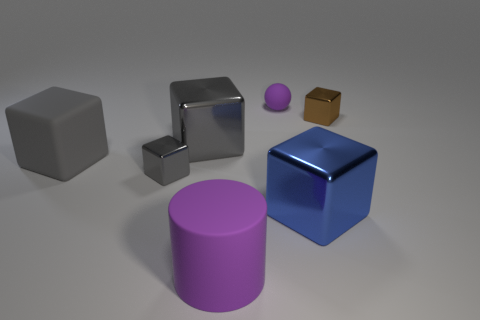There is another small shiny object that is the same shape as the tiny gray object; what is its color?
Offer a very short reply. Brown. Are there more large blue shiny objects behind the big blue metal object than large blue metallic things that are behind the large gray matte thing?
Offer a very short reply. No. How many other things are there of the same shape as the big gray shiny object?
Make the answer very short. 4. Is there a gray cube behind the tiny shiny cube on the left side of the large rubber cylinder?
Provide a short and direct response. Yes. How many brown shiny blocks are there?
Make the answer very short. 1. There is a tiny matte ball; is it the same color as the big rubber thing in front of the blue metallic block?
Your response must be concise. Yes. Are there more small purple spheres than tiny red shiny cylinders?
Keep it short and to the point. Yes. Are there any other things of the same color as the big rubber block?
Your response must be concise. Yes. How many other things are the same size as the gray rubber object?
Keep it short and to the point. 3. What material is the purple object that is in front of the matte thing behind the big metal cube that is behind the big rubber block?
Give a very brief answer. Rubber. 